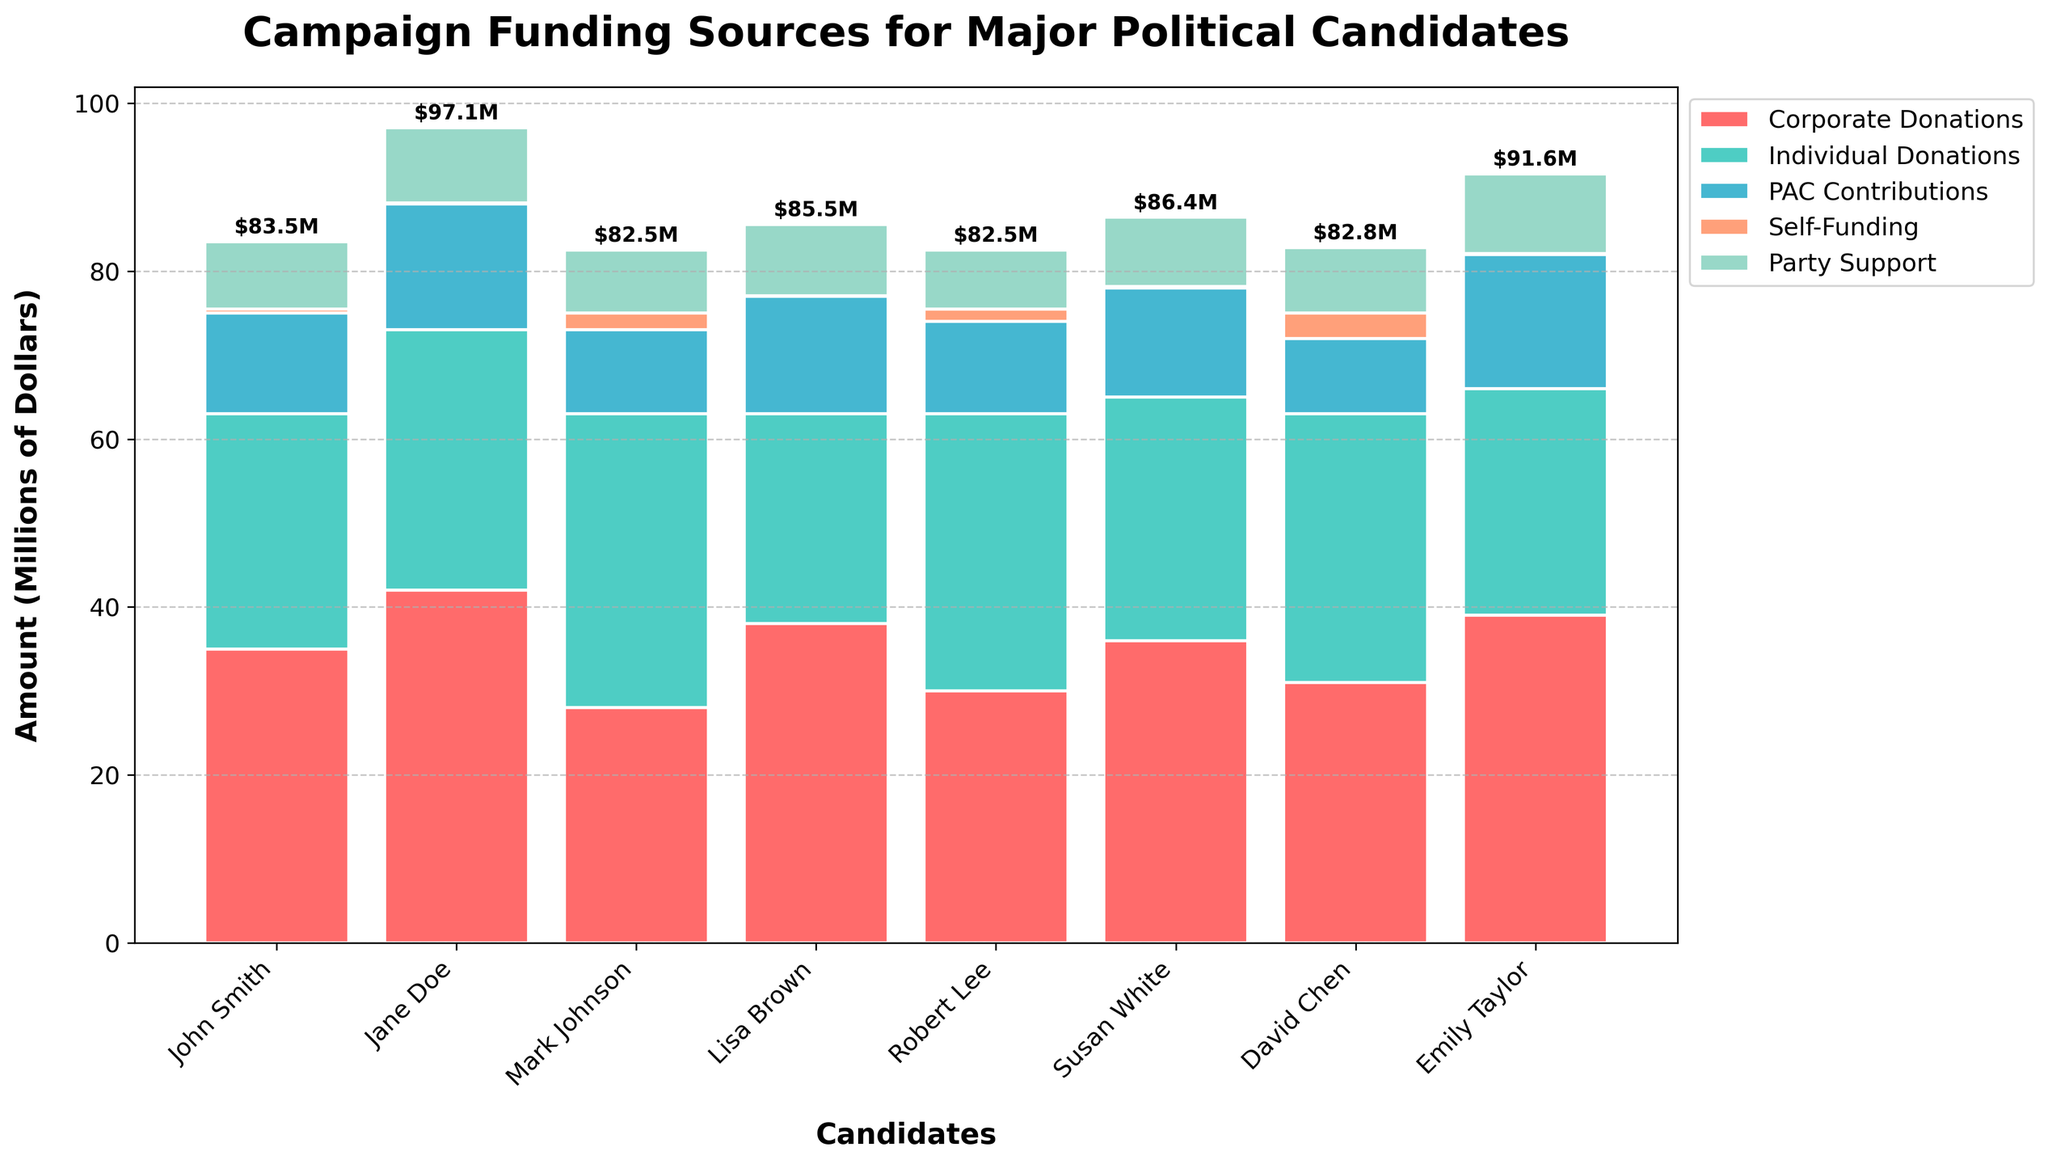How much more in Individual Donations did Mark Johnson raise compared to Lisa Brown? Mark Johnson raised $35 million in Individual Donations while Lisa Brown raised $25 million, so the difference is $35M - $25M.
Answer: $10M Which candidate received the highest amount from Corporate Donations and how much did they receive? Jane Doe received the highest amount from Corporate Donations, which is $42 million.
Answer: Jane Doe, $42M Comparing Self-Funding sources, by how much does David Chen exceed Susan White? David Chen received $3 million in Self-Funding, while Susan White received $0.2 million. The difference is $3M - $0.2M.
Answer: $2.8M Which candidate has the smallest total campaign funding and what is the total amount? Total amounts for candidates need to be summed from the components: John Smith ($84.5M), Jane Doe ($97.1M), Mark Johnson ($82M), Lisa Brown ($78.55M), Robert Lee ($82M), Susan White ($84.2M), David Chen ($82.3M), and Emily Taylor ($91.75M). Lisa Brown has the smallest total funding of $78.55M.
Answer: Lisa Brown, $78.55M What is the total amount of PAC Contributions for John Smith and Jane Doe combined? Adding PAC Contributions for John Smith ($12M) and Jane Doe ($15M), the total is $12M + $15M.
Answer: $27M Which candidate has the largest single category contribution and what category is it? The largest single category contribution is Jane Doe's Corporate Donations of $42 million.
Answer: Jane Doe, Corporate Donations What are the combined Self-Funding amounts for all candidates? Adding the Self-Funding amounts for all candidates: $0.5M (John Smith) + $0.1M (Jane Doe) + $2M (Mark Johnson) + $0.05M (Lisa Brown) + $1.5M (Robert Lee) + $0.2M (Susan White) + $3M (David Chen) + $0.075M (Emily Taylor) equals $7.425M but when rounded to M's it's 7.4M.
Answer: $7.4M How does Robert Lee's total Party Support compare to Emily Taylor's? Robert Lee received $7M in Party Support while Emily Taylor received $9.5M, so Emily Taylor received more.
Answer: Emily Taylor received $2.5M more 